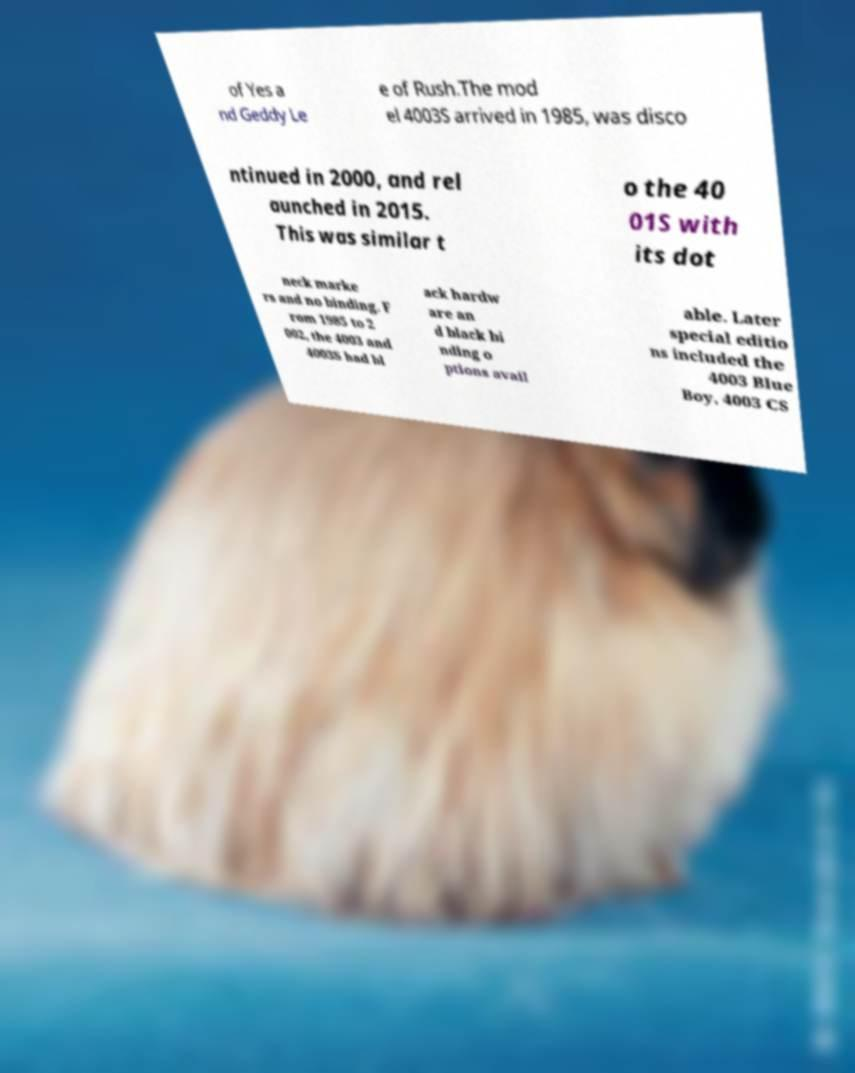What messages or text are displayed in this image? I need them in a readable, typed format. of Yes a nd Geddy Le e of Rush.The mod el 4003S arrived in 1985, was disco ntinued in 2000, and rel aunched in 2015. This was similar t o the 40 01S with its dot neck marke rs and no binding. F rom 1985 to 2 002, the 4003 and 4003S had bl ack hardw are an d black bi nding o ptions avail able. Later special editio ns included the 4003 Blue Boy, 4003 CS 